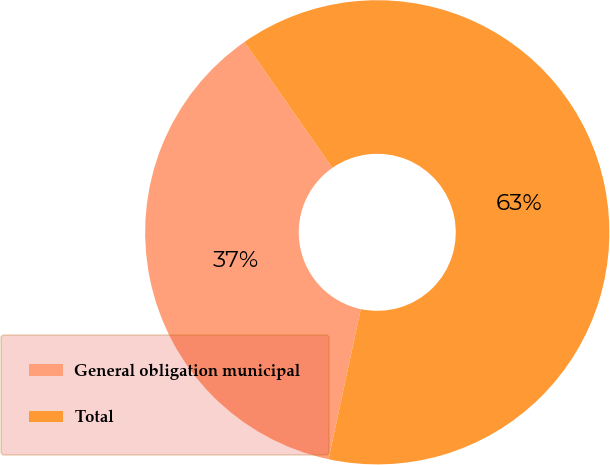<chart> <loc_0><loc_0><loc_500><loc_500><pie_chart><fcel>General obligation municipal<fcel>Total<nl><fcel>36.94%<fcel>63.06%<nl></chart> 